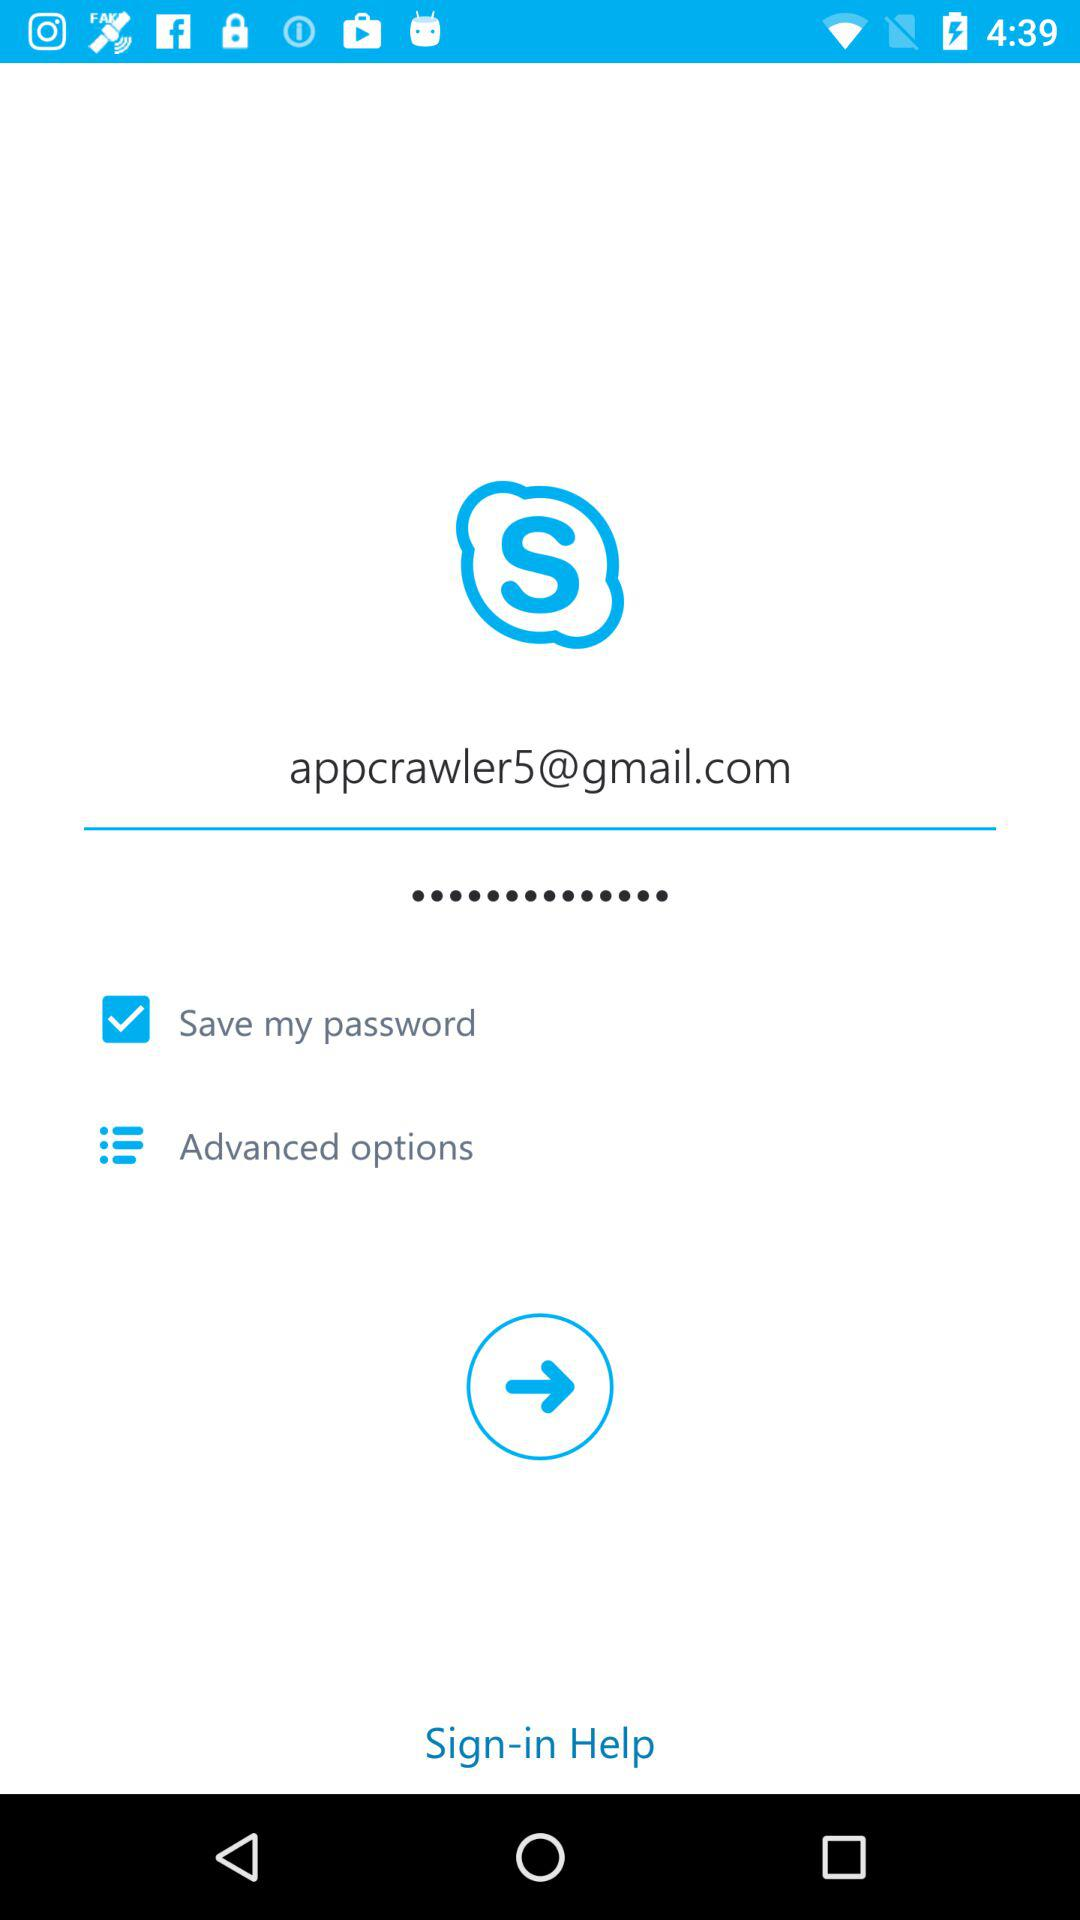What is the status of "Save my password"? The status is "on". 